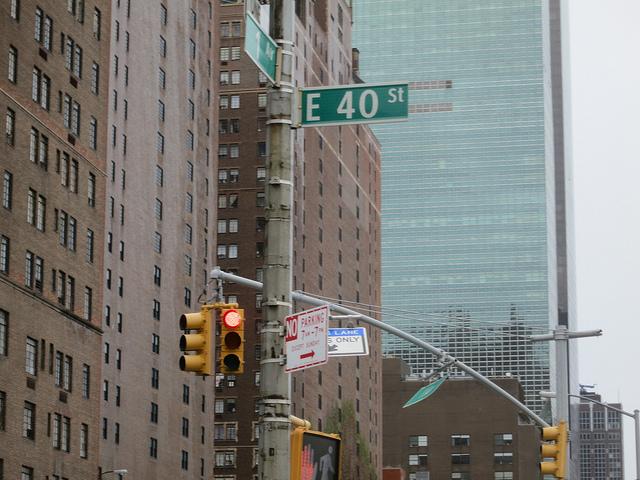What color is the traffic light?
Keep it brief. Red. Is this a town in Asia?
Concise answer only. No. How many traffic lights are there?
Be succinct. 2. Is This an Avenue?
Short answer required. No. What is the name of the Avenue that meets 40 Street at this corner?
Be succinct. 1 ave. What will be the next Avenue if they go in succession?
Give a very brief answer. 41st. How many arrows are in this image?
Concise answer only. 1. What street number is this?
Concise answer only. 40. What does the street sign say?
Give a very brief answer. E 40 st. What number is on the street sign?
Write a very short answer. 40. The buildings on the left built from what?
Answer briefly. Brick. 